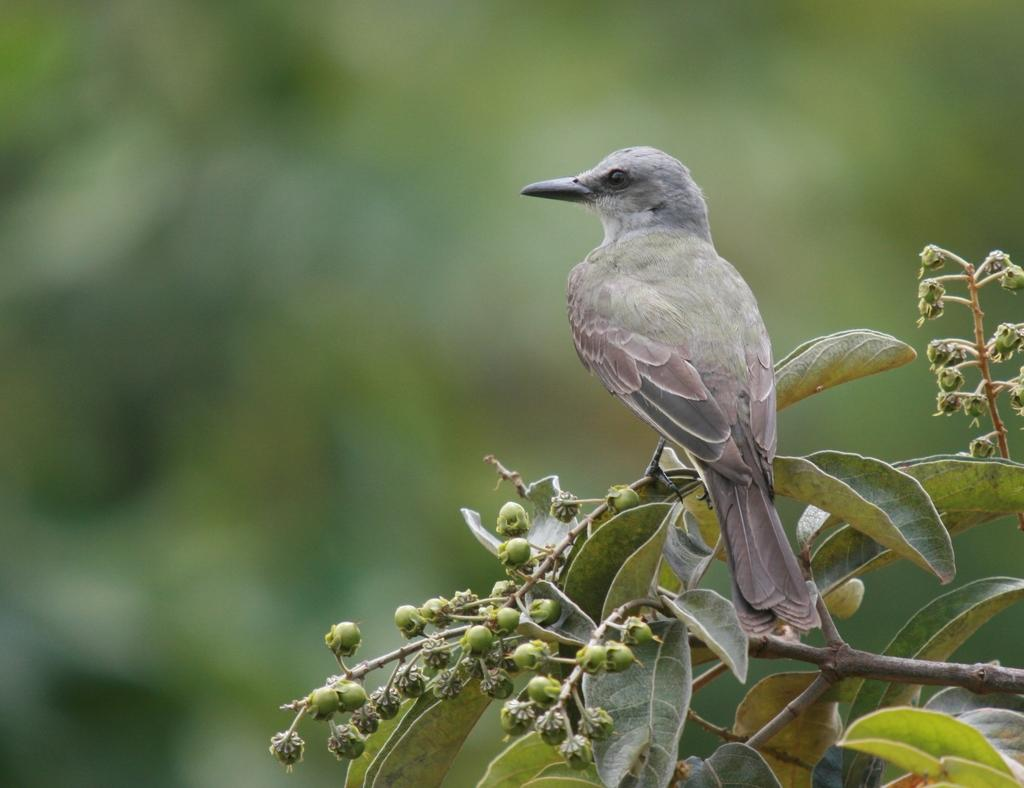What type of animal is in the image? There is a bird in the image. Where is the bird located? The bird is sitting on a plant. Can you describe the bird's color? The bird is in ash and grey color. What is the plant's condition? There are buds on the plant. How would you describe the background of the image? The background of the image is blurred. What type of building can be seen in the background of the image? There is no building present in the image; it features a bird sitting on a plant with a blurred background. 